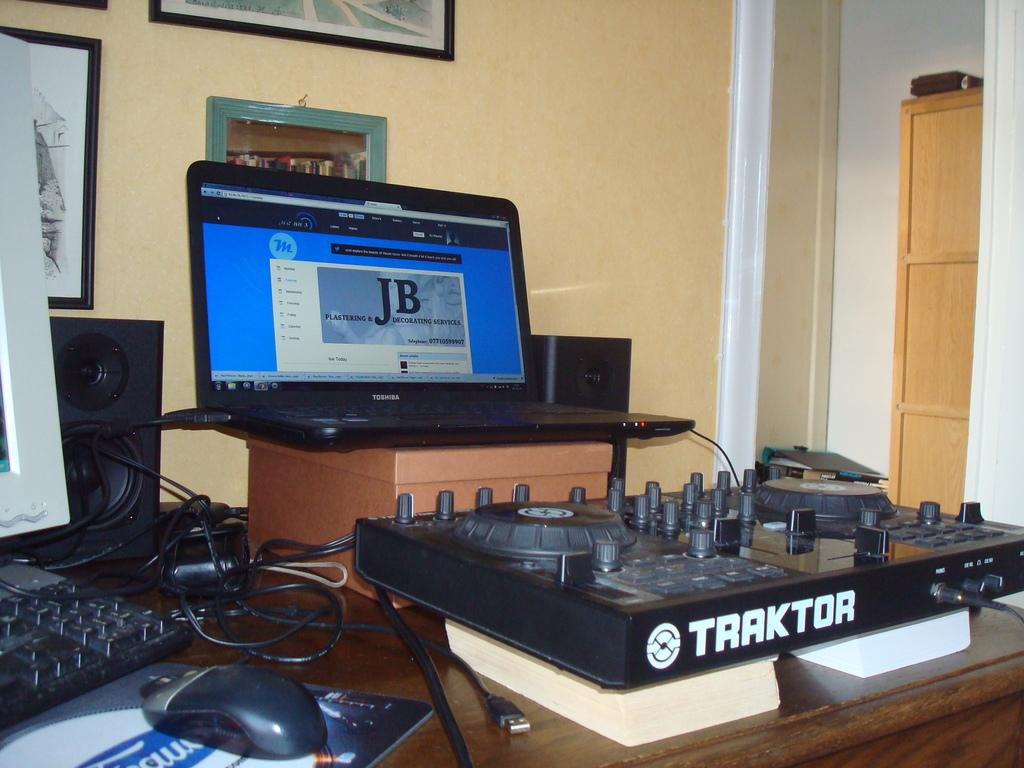<image>
Share a concise interpretation of the image provided. Black Traktor DJ device in front of a laptop and monitor. 